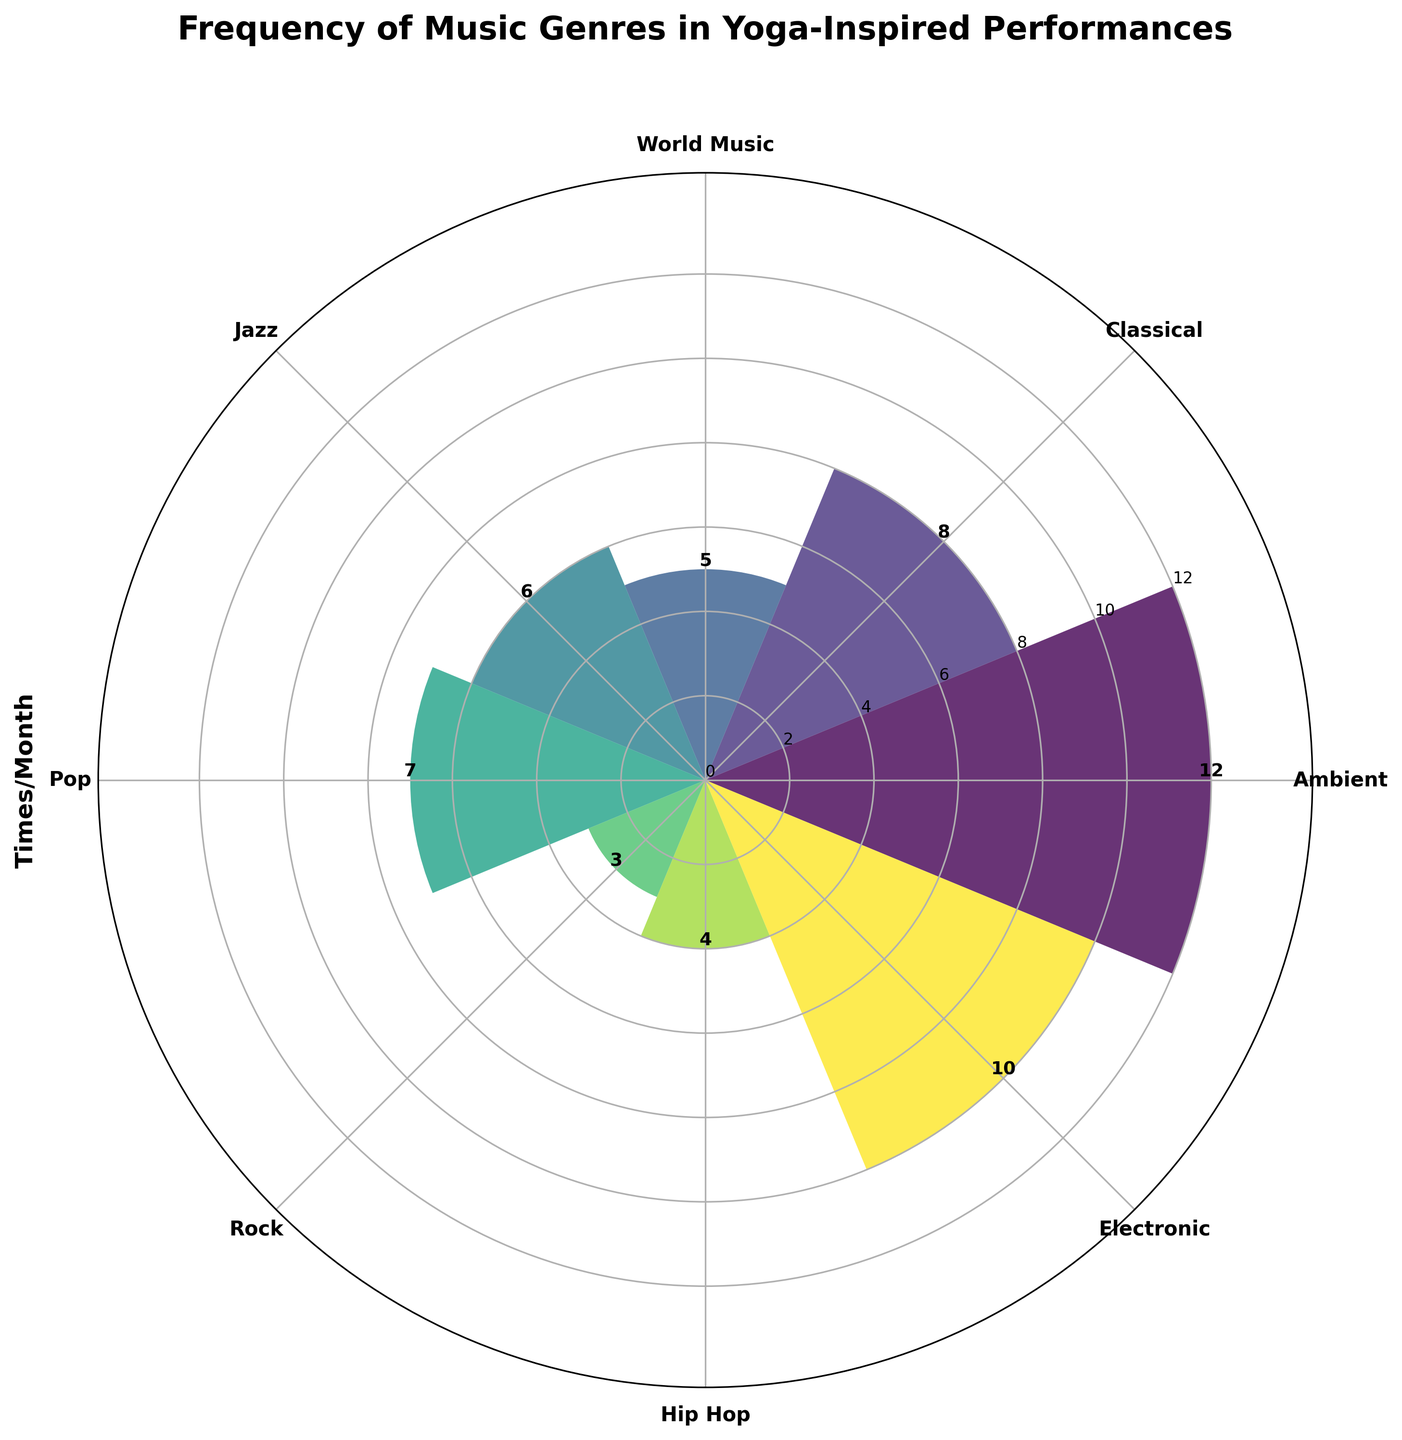What is the title of the chart? The title is typically located at the top of the chart and provides an overview of what the chart represents.
Answer: Frequency of Music Genres in Yoga-Inspired Performances What music genre is incorporated the most frequently in performances? By observing the height of the bars in the polar chart, the tallest bar indicates the most frequently incorporated genre.
Answer: Ambient How many times per month is Jazz incorporated into your performances? The bar corresponding to Jazz will have a height indicating its frequency, which is labeled.
Answer: 6 Which genre is used more frequently: Rock or Electronic? Compare the heights of the bars for Rock and Electronic; the taller bar represents the more frequently used genre.
Answer: Electronic What is the combined frequency of using Classical and Pop music in performances? Add the frequencies associated with Classical and Pop by referring to the bar heights of both. Classical is 8 and Pop is 7; thus, 8 + 7 = 15.
Answer: 15 Which genres are used fewer than 5 times per month? Identify and list the bars with heights less than 5. Rock (3) and World Music (5) are observed, but only Rock is fewer than 5.
Answer: Rock What is the difference in frequency between Hip Hop and World Music? Subtract the smaller frequency from the larger one by referring to their bar heights: World Music is 5, Hip Hop is 4. Hence, 5 - 4 = 1.
Answer: 1 How many genres are represented in the chart? Count the number of distinct bars or labels around the polar chart.
Answer: 8 What is the median frequency of incorporating different genres into performances? List the frequencies in ascending order (3, 4, 5, 6, 7, 8, 10, 12), and find the middle values. The median is the average of the 4th and 5th values: (6+7)/2 = 6.5.
Answer: 6.5 How does the height of the Ambient bar compare to the Electronic bar? By comparing the heights of the bars, observe that the Ambient bar (12) has a higher value than the Electronic bar (10).
Answer: Ambient is higher 